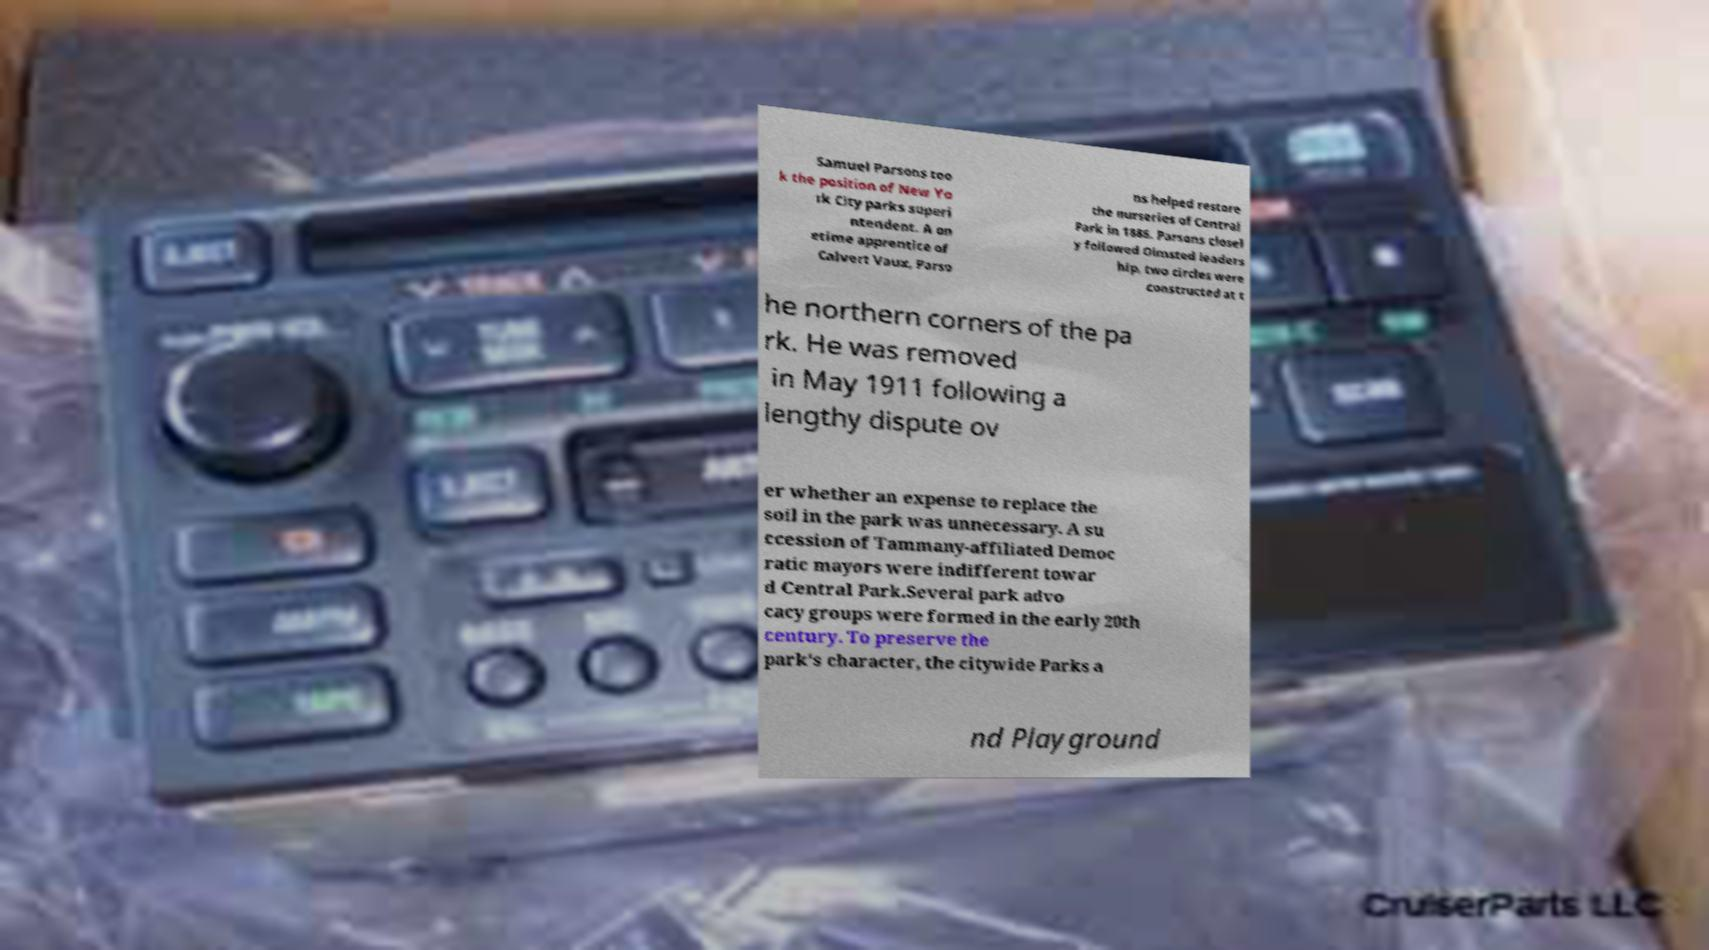I need the written content from this picture converted into text. Can you do that? Samuel Parsons too k the position of New Yo rk City parks superi ntendent. A on etime apprentice of Calvert Vaux, Parso ns helped restore the nurseries of Central Park in 1886. Parsons closel y followed Olmsted leaders hip, two circles were constructed at t he northern corners of the pa rk. He was removed in May 1911 following a lengthy dispute ov er whether an expense to replace the soil in the park was unnecessary. A su ccession of Tammany-affiliated Democ ratic mayors were indifferent towar d Central Park.Several park advo cacy groups were formed in the early 20th century. To preserve the park's character, the citywide Parks a nd Playground 